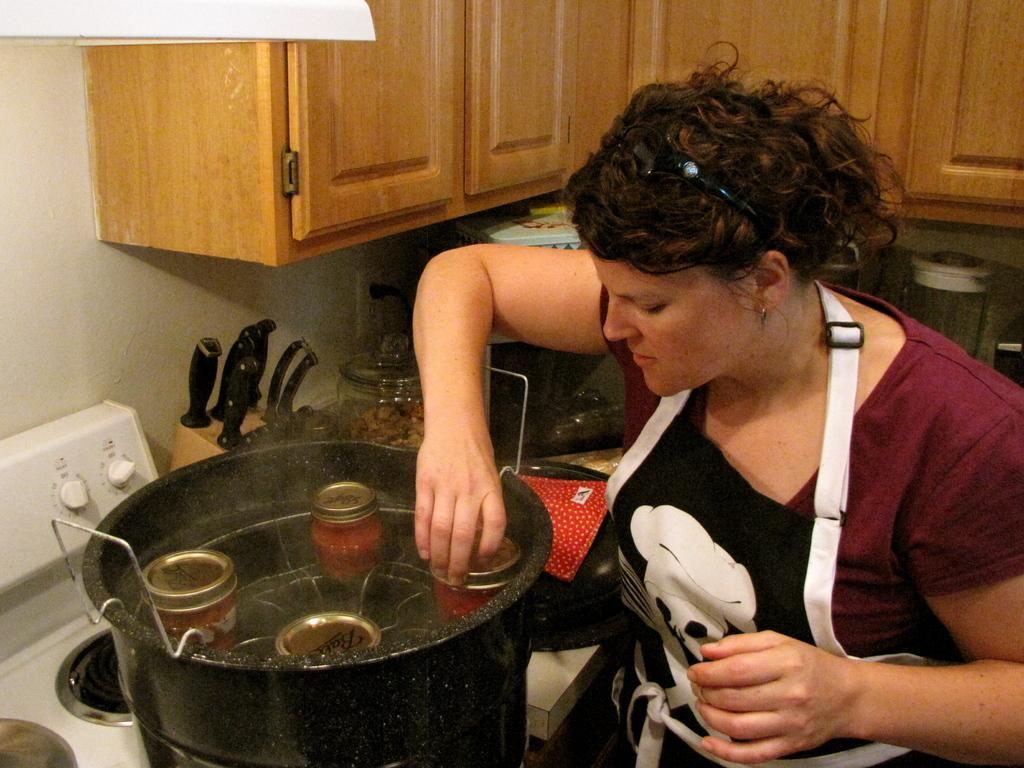Who is the main subject in the image? There is a lady in the image. What is the lady wearing? The lady is wearing an apron. What activity is the lady engaged in? The lady appears to be cooking. What can be seen in the background of the image? In the background of the image, there are cupboards, kitchenware, glass containers, and other objects. What type of lip can be seen on the lady's face in the image? There is no lip visible on the lady's face in the image. What word is the lady saying while cooking in the image? The image does not provide any information about the lady's speech or the words she might be saying. 